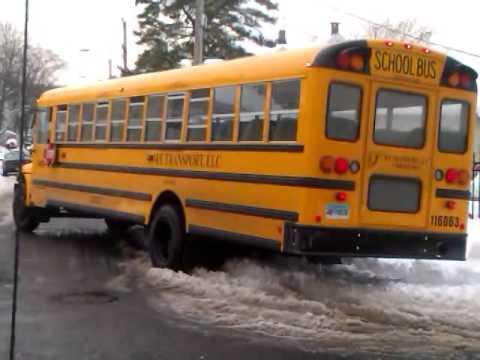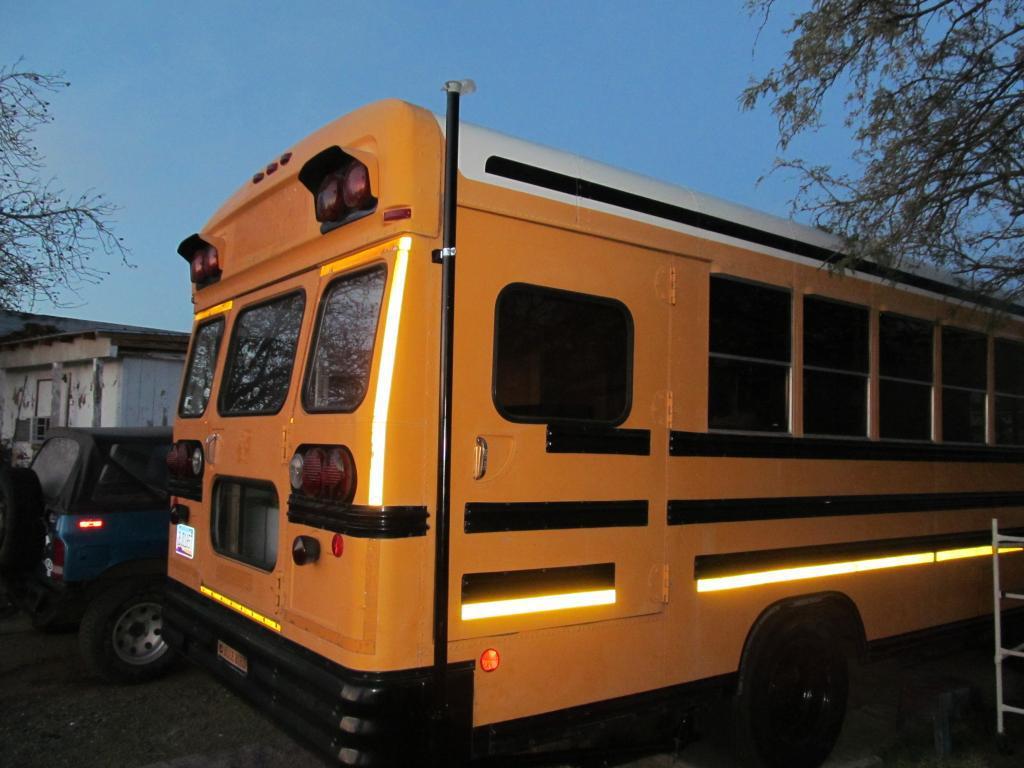The first image is the image on the left, the second image is the image on the right. For the images displayed, is the sentence "The left and right image contains the same number of buses." factually correct? Answer yes or no. Yes. 